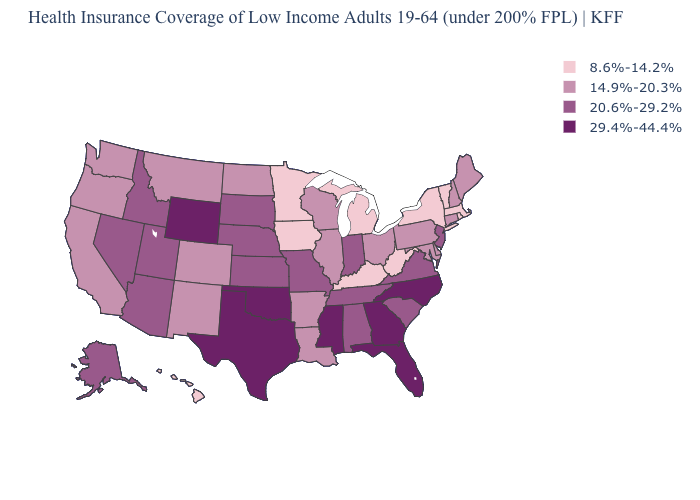Does Ohio have the same value as North Carolina?
Answer briefly. No. Name the states that have a value in the range 8.6%-14.2%?
Be succinct. Hawaii, Iowa, Kentucky, Massachusetts, Michigan, Minnesota, New York, Rhode Island, Vermont, West Virginia. How many symbols are there in the legend?
Quick response, please. 4. Does Maine have a lower value than Utah?
Be succinct. Yes. What is the value of North Carolina?
Quick response, please. 29.4%-44.4%. What is the highest value in the Northeast ?
Give a very brief answer. 20.6%-29.2%. Does Connecticut have a lower value than New Hampshire?
Keep it brief. No. Does Kentucky have the lowest value in the South?
Quick response, please. Yes. What is the lowest value in states that border Minnesota?
Be succinct. 8.6%-14.2%. Which states have the lowest value in the USA?
Concise answer only. Hawaii, Iowa, Kentucky, Massachusetts, Michigan, Minnesota, New York, Rhode Island, Vermont, West Virginia. What is the highest value in states that border South Dakota?
Concise answer only. 29.4%-44.4%. Among the states that border Utah , does Arizona have the lowest value?
Answer briefly. No. What is the lowest value in the USA?
Give a very brief answer. 8.6%-14.2%. Name the states that have a value in the range 14.9%-20.3%?
Be succinct. Arkansas, California, Colorado, Connecticut, Delaware, Illinois, Louisiana, Maine, Maryland, Montana, New Hampshire, New Mexico, North Dakota, Ohio, Oregon, Pennsylvania, Washington, Wisconsin. Does the first symbol in the legend represent the smallest category?
Short answer required. Yes. 